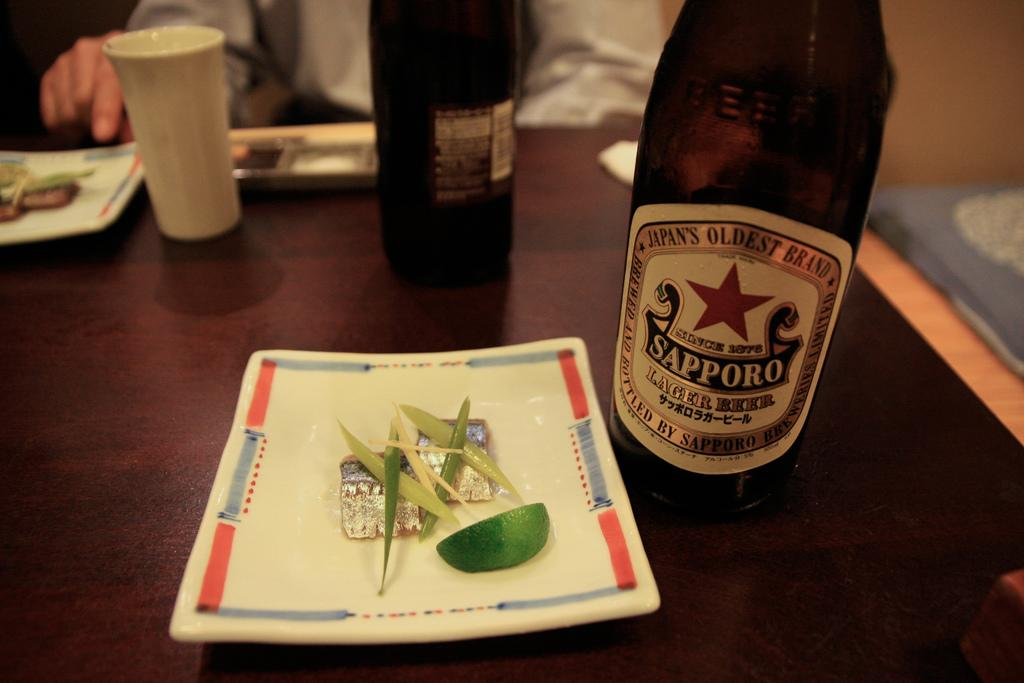What type of containers can be seen on the table in the image? There are bottles on the table in the image. What else can be seen on the table besides the bottles? There is a glass, objects on a plate, and other objects on the table. What is the table made of? The table is made of wood. Can you describe the person in the background? There is a person sitting in the background, but no specific details are provided about them. Are there any cobwebs visible on the table in the image? There is no mention of cobwebs in the provided facts, so we cannot determine if any are present in the image. What direction is the person in the background walking in? There is no indication of the person's movement or direction in the image, as they are simply sitting in the background. 